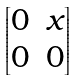Convert formula to latex. <formula><loc_0><loc_0><loc_500><loc_500>\begin{bmatrix} 0 & x \\ 0 & 0 \end{bmatrix}</formula> 